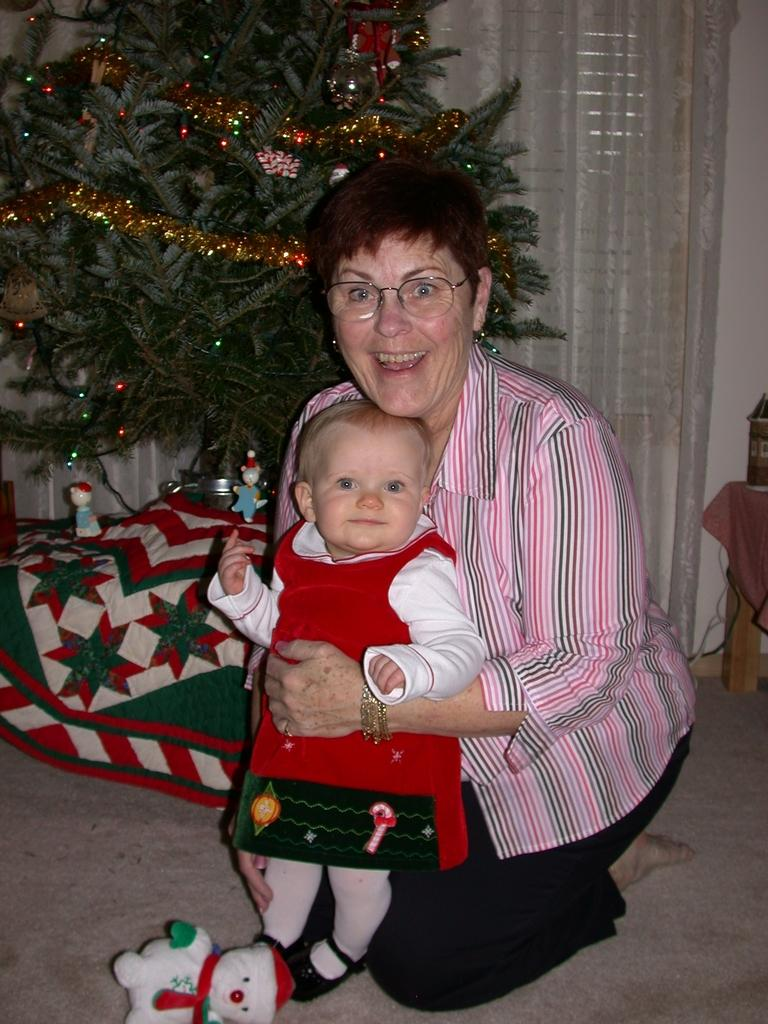Who is in the foreground of the image? There is a woman and a baby in the foreground of the image. What are the woman and baby doing in the image? The woman and baby are on the floor. What can be seen in the background of the image? There is a bed, a Christmas tree, a curtain, a wall, and a table in the background of the image. What type of room might the image be taken in? The image is likely taken in a room, as it contains furniture and decorations typically found in a room. What type of fang can be seen in the image? There are no fangs present in the image. How many grapes are on the table in the image? There is no table with grapes in the image; the table in the background has other items on it. 